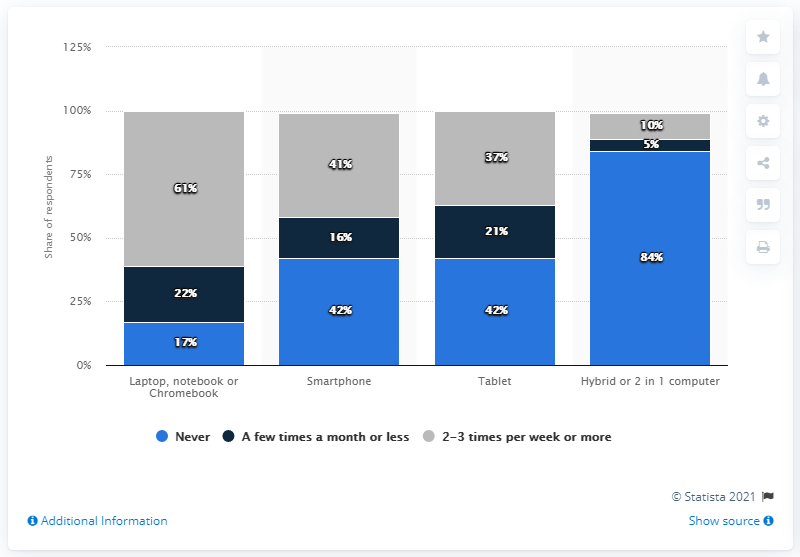Draw attention to some important aspects in this diagram. The study found that there was a significant difference in the number of students who answered "never" for tablets compared to those who answered the same for hybrid or 2 in 1 computers. Specifically, there were 42 more students who answered "never" for tablets than for hybrid or 2 in 1 computers. The highest response for students who use their smartphones for schoolwork is "Never. 